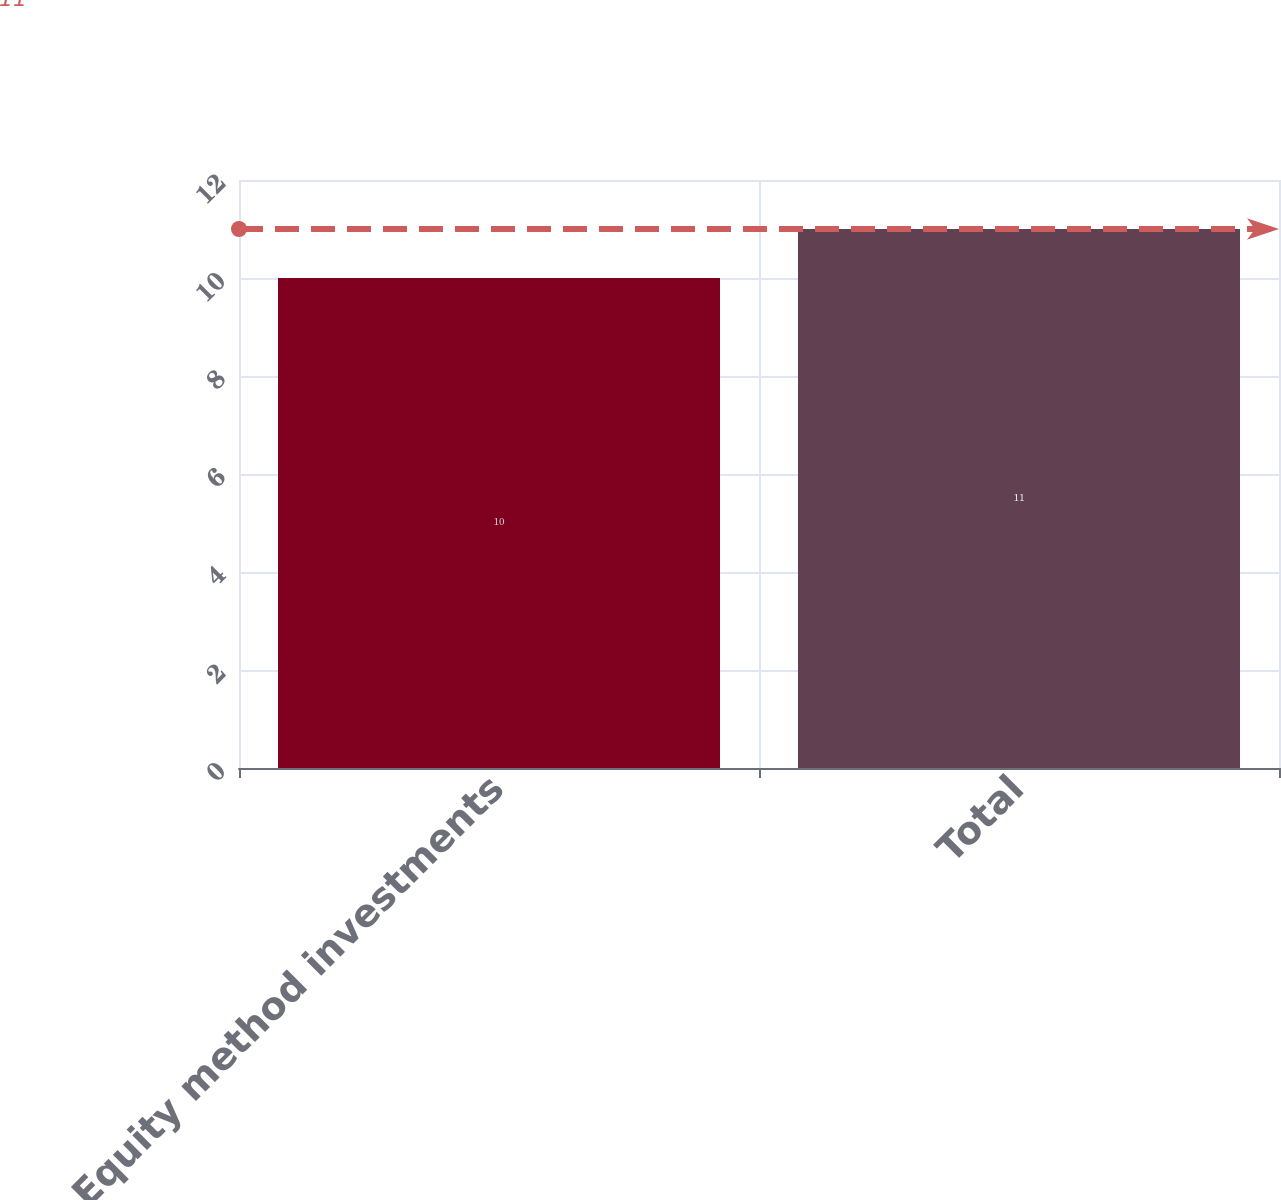Convert chart. <chart><loc_0><loc_0><loc_500><loc_500><bar_chart><fcel>Equity method investments<fcel>Total<nl><fcel>10<fcel>11<nl></chart> 